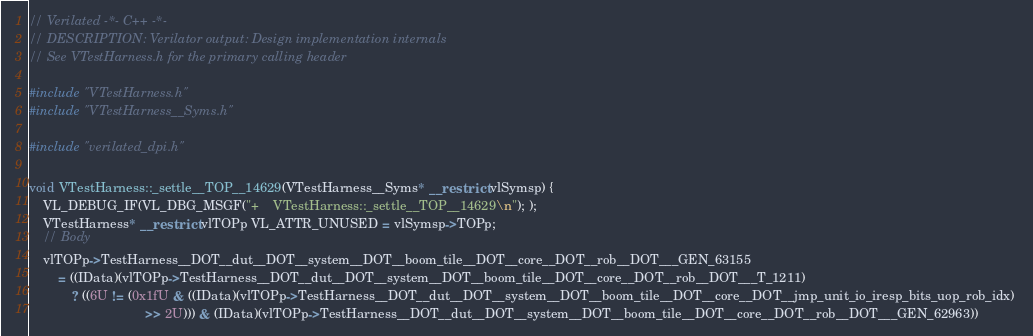Convert code to text. <code><loc_0><loc_0><loc_500><loc_500><_C++_>// Verilated -*- C++ -*-
// DESCRIPTION: Verilator output: Design implementation internals
// See VTestHarness.h for the primary calling header

#include "VTestHarness.h"
#include "VTestHarness__Syms.h"

#include "verilated_dpi.h"

void VTestHarness::_settle__TOP__14629(VTestHarness__Syms* __restrict vlSymsp) {
    VL_DEBUG_IF(VL_DBG_MSGF("+    VTestHarness::_settle__TOP__14629\n"); );
    VTestHarness* __restrict vlTOPp VL_ATTR_UNUSED = vlSymsp->TOPp;
    // Body
    vlTOPp->TestHarness__DOT__dut__DOT__system__DOT__boom_tile__DOT__core__DOT__rob__DOT___GEN_63155 
        = ((IData)(vlTOPp->TestHarness__DOT__dut__DOT__system__DOT__boom_tile__DOT__core__DOT__rob__DOT___T_1211)
            ? ((6U != (0x1fU & ((IData)(vlTOPp->TestHarness__DOT__dut__DOT__system__DOT__boom_tile__DOT__core__DOT__jmp_unit_io_iresp_bits_uop_rob_idx) 
                                >> 2U))) & (IData)(vlTOPp->TestHarness__DOT__dut__DOT__system__DOT__boom_tile__DOT__core__DOT__rob__DOT___GEN_62963))</code> 